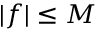Convert formula to latex. <formula><loc_0><loc_0><loc_500><loc_500>| f | \leq { M }</formula> 